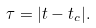<formula> <loc_0><loc_0><loc_500><loc_500>\tau = | t - t _ { c } | .</formula> 